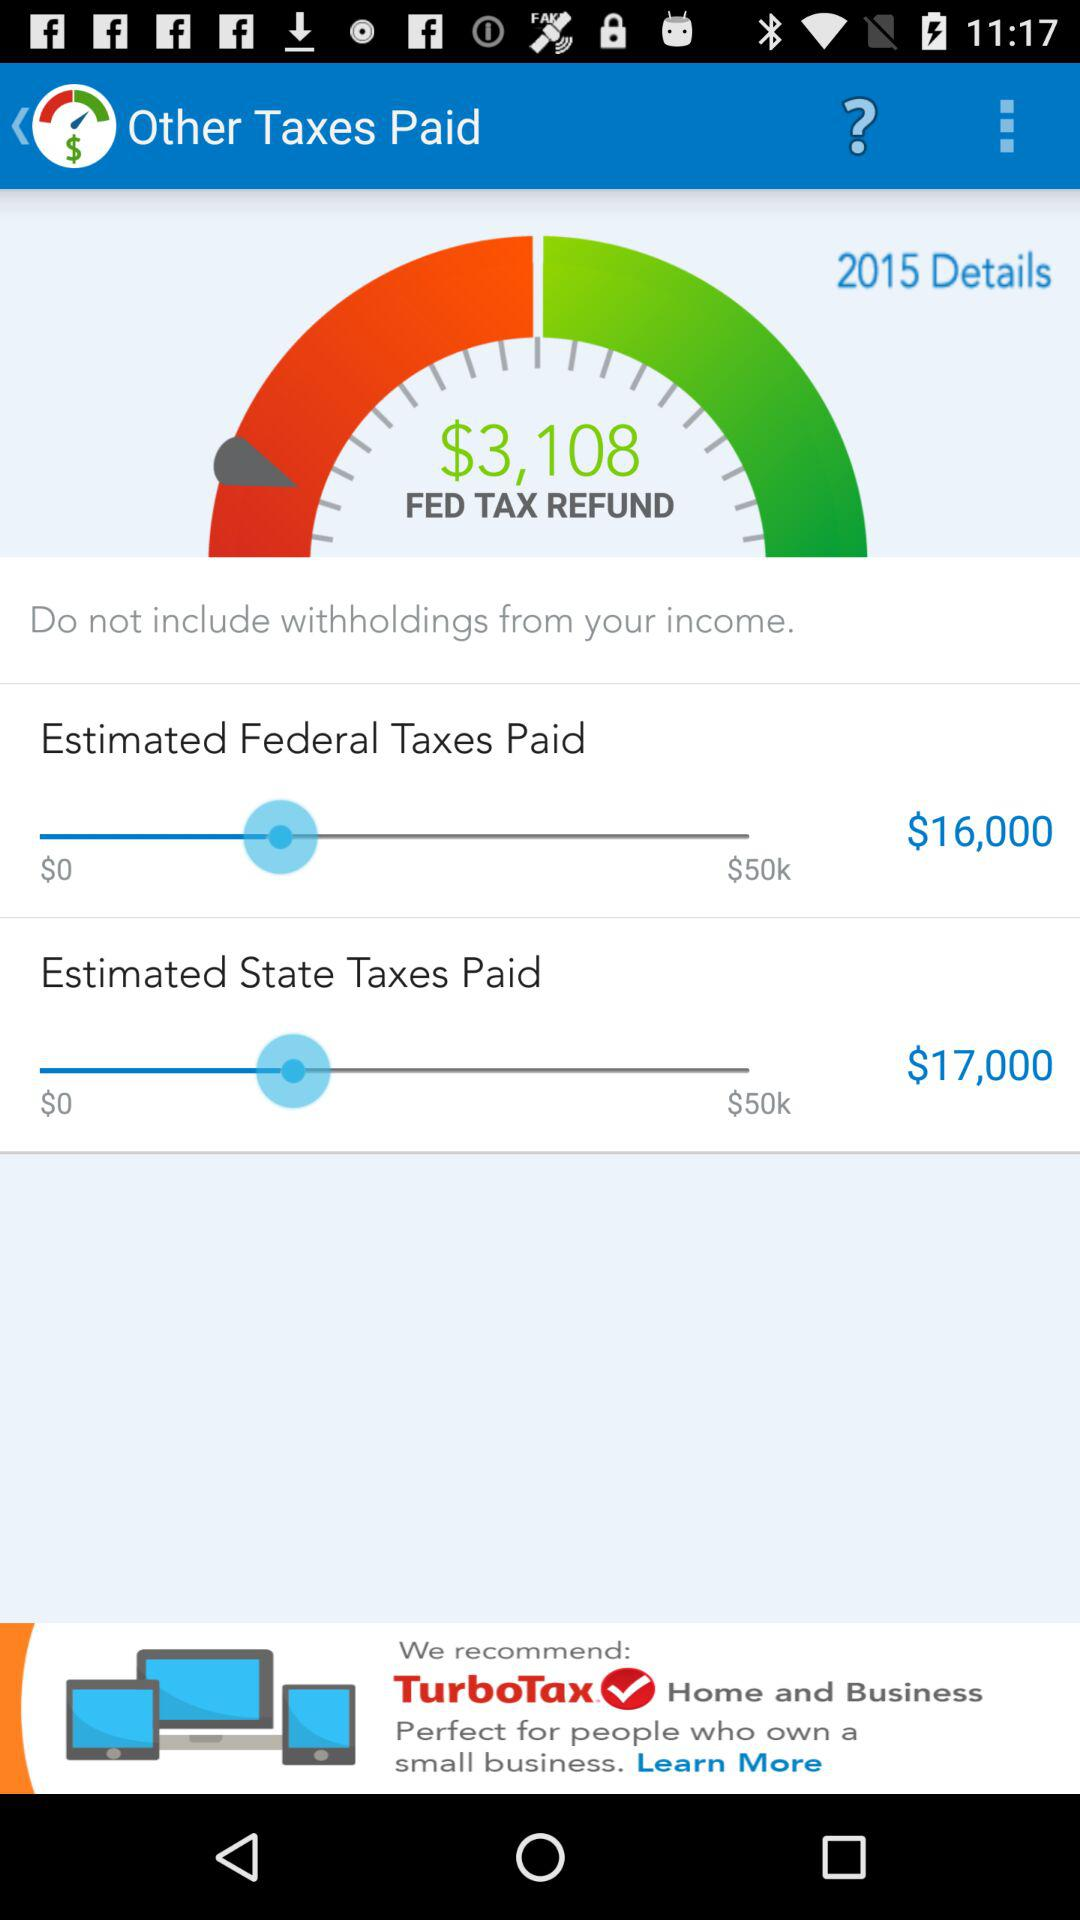What's the set amount for "Estimated Federal Taxes Paid"? The set amount for "Estimated Federal Taxes Paid" is $16,000. 